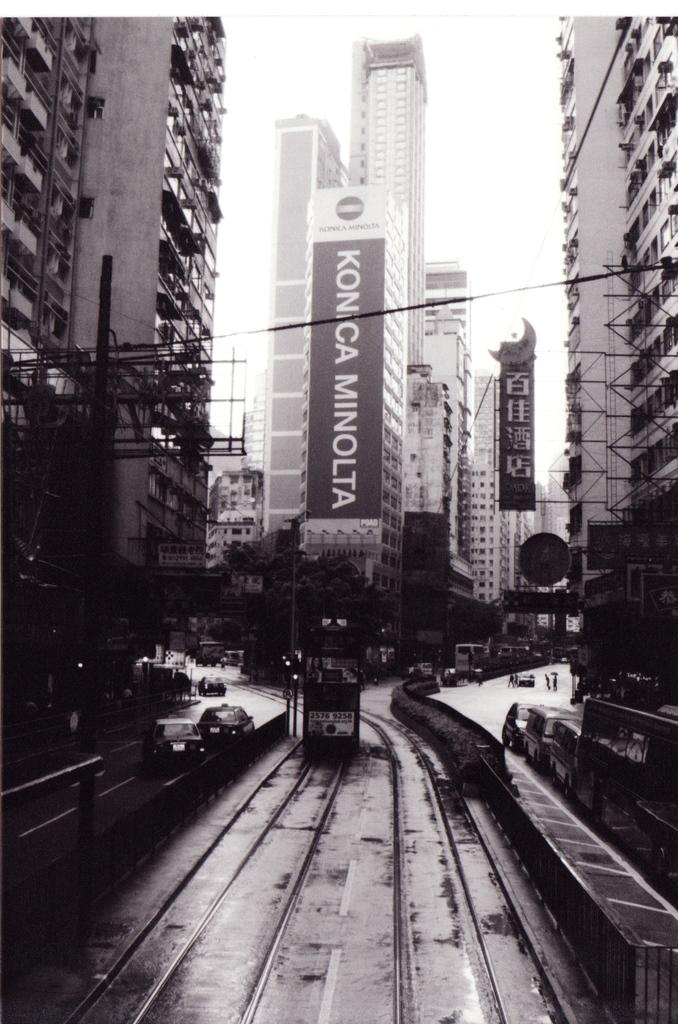<image>
Share a concise interpretation of the image provided. A trolley car is on tracks with a Konica Minolta banner the size of a building in the background. 